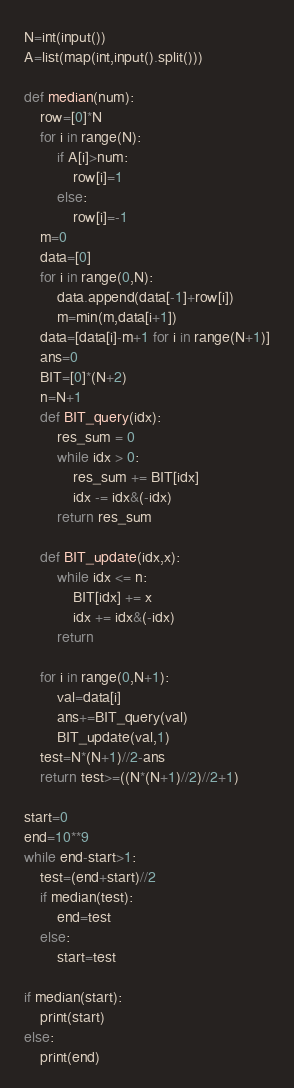<code> <loc_0><loc_0><loc_500><loc_500><_Python_>N=int(input())
A=list(map(int,input().split()))

def median(num):
    row=[0]*N
    for i in range(N):
        if A[i]>num:
            row[i]=1
        else:
            row[i]=-1
    m=0
    data=[0]
    for i in range(0,N):
        data.append(data[-1]+row[i])
        m=min(m,data[i+1])
    data=[data[i]-m+1 for i in range(N+1)]
    ans=0
    BIT=[0]*(N+2)
    n=N+1
    def BIT_query(idx):
        res_sum = 0
        while idx > 0:
            res_sum += BIT[idx]
            idx -= idx&(-idx)
        return res_sum

    def BIT_update(idx,x):
        while idx <= n:
            BIT[idx] += x
            idx += idx&(-idx)
        return

    for i in range(0,N+1):
        val=data[i]
        ans+=BIT_query(val)
        BIT_update(val,1)
    test=N*(N+1)//2-ans
    return test>=((N*(N+1)//2)//2+1)

start=0
end=10**9
while end-start>1:
    test=(end+start)//2
    if median(test):
        end=test
    else:
        start=test

if median(start):
    print(start)
else:
    print(end)</code> 